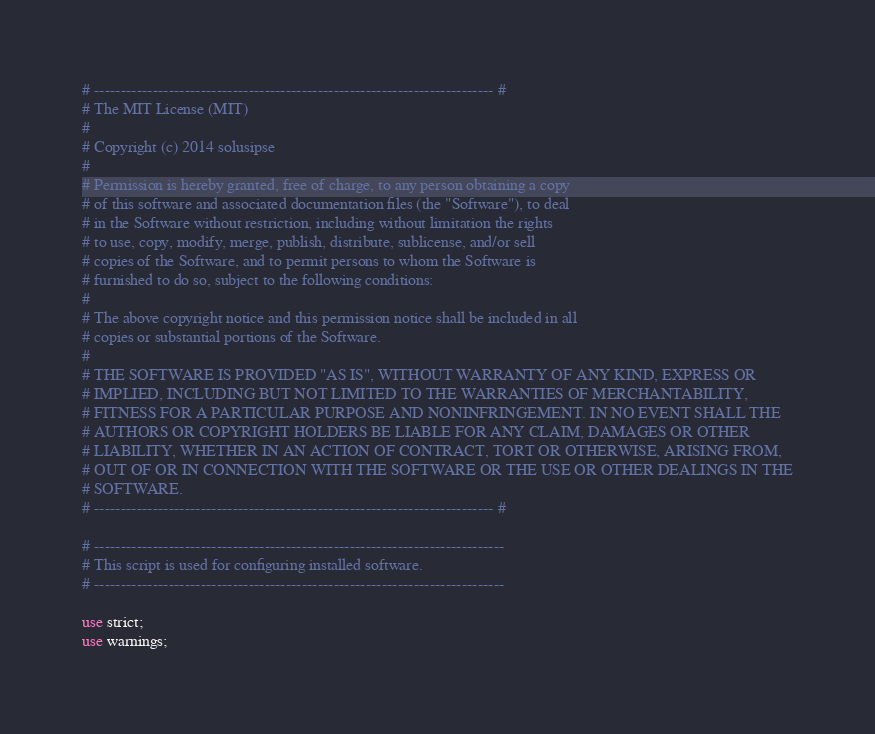Convert code to text. <code><loc_0><loc_0><loc_500><loc_500><_Perl_>
# --------------------------------------------------------------------------- #
# The MIT License (MIT)
#
# Copyright (c) 2014 solusipse
#
# Permission is hereby granted, free of charge, to any person obtaining a copy
# of this software and associated documentation files (the "Software"), to deal
# in the Software without restriction, including without limitation the rights
# to use, copy, modify, merge, publish, distribute, sublicense, and/or sell
# copies of the Software, and to permit persons to whom the Software is
# furnished to do so, subject to the following conditions:
#
# The above copyright notice and this permission notice shall be included in all
# copies or substantial portions of the Software.
#
# THE SOFTWARE IS PROVIDED "AS IS", WITHOUT WARRANTY OF ANY KIND, EXPRESS OR
# IMPLIED, INCLUDING BUT NOT LIMITED TO THE WARRANTIES OF MERCHANTABILITY,
# FITNESS FOR A PARTICULAR PURPOSE AND NONINFRINGEMENT. IN NO EVENT SHALL THE
# AUTHORS OR COPYRIGHT HOLDERS BE LIABLE FOR ANY CLAIM, DAMAGES OR OTHER
# LIABILITY, WHETHER IN AN ACTION OF CONTRACT, TORT OR OTHERWISE, ARISING FROM,
# OUT OF OR IN CONNECTION WITH THE SOFTWARE OR THE USE OR OTHER DEALINGS IN THE
# SOFTWARE.
# --------------------------------------------------------------------------- #

# -----------------------------------------------------------------------------
# This script is used for configuring installed software.
# -----------------------------------------------------------------------------

use strict;
use warnings;


</code> 